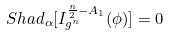<formula> <loc_0><loc_0><loc_500><loc_500>S h a d _ { \alpha } [ I ^ { \frac { n } { 2 } - A _ { 1 } } _ { g ^ { n } } ( \phi ) ] = 0</formula> 